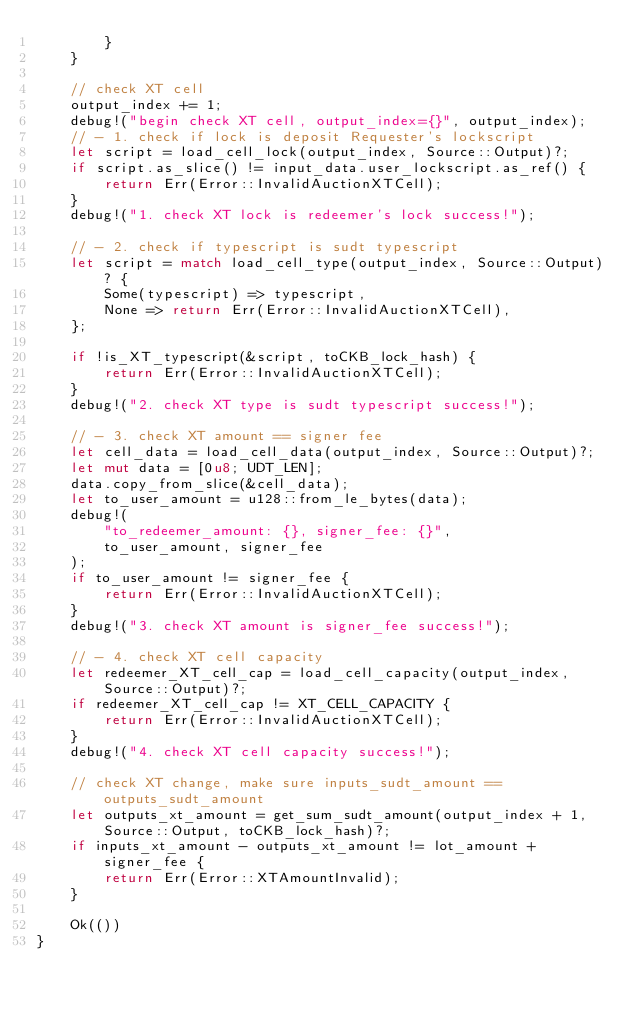Convert code to text. <code><loc_0><loc_0><loc_500><loc_500><_Rust_>        }
    }

    // check XT cell
    output_index += 1;
    debug!("begin check XT cell, output_index={}", output_index);
    // - 1. check if lock is deposit Requester's lockscript
    let script = load_cell_lock(output_index, Source::Output)?;
    if script.as_slice() != input_data.user_lockscript.as_ref() {
        return Err(Error::InvalidAuctionXTCell);
    }
    debug!("1. check XT lock is redeemer's lock success!");

    // - 2. check if typescript is sudt typescript
    let script = match load_cell_type(output_index, Source::Output)? {
        Some(typescript) => typescript,
        None => return Err(Error::InvalidAuctionXTCell),
    };

    if !is_XT_typescript(&script, toCKB_lock_hash) {
        return Err(Error::InvalidAuctionXTCell);
    }
    debug!("2. check XT type is sudt typescript success!");

    // - 3. check XT amount == signer fee
    let cell_data = load_cell_data(output_index, Source::Output)?;
    let mut data = [0u8; UDT_LEN];
    data.copy_from_slice(&cell_data);
    let to_user_amount = u128::from_le_bytes(data);
    debug!(
        "to_redeemer_amount: {}, signer_fee: {}",
        to_user_amount, signer_fee
    );
    if to_user_amount != signer_fee {
        return Err(Error::InvalidAuctionXTCell);
    }
    debug!("3. check XT amount is signer_fee success!");

    // - 4. check XT cell capacity
    let redeemer_XT_cell_cap = load_cell_capacity(output_index, Source::Output)?;
    if redeemer_XT_cell_cap != XT_CELL_CAPACITY {
        return Err(Error::InvalidAuctionXTCell);
    }
    debug!("4. check XT cell capacity success!");

    // check XT change, make sure inputs_sudt_amount == outputs_sudt_amount
    let outputs_xt_amount = get_sum_sudt_amount(output_index + 1, Source::Output, toCKB_lock_hash)?;
    if inputs_xt_amount - outputs_xt_amount != lot_amount + signer_fee {
        return Err(Error::XTAmountInvalid);
    }

    Ok(())
}
</code> 